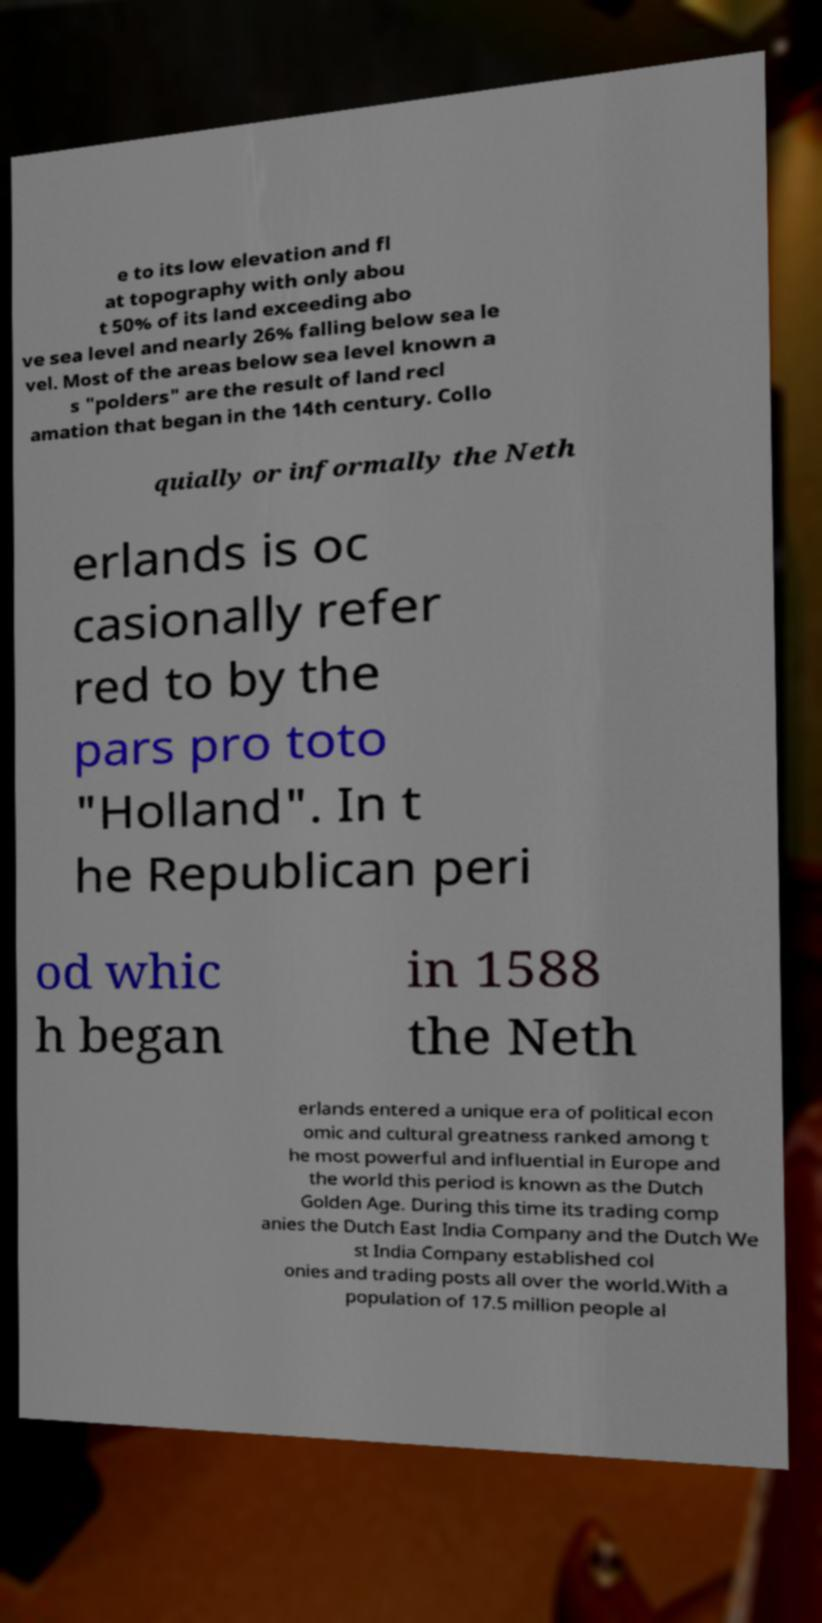Can you accurately transcribe the text from the provided image for me? e to its low elevation and fl at topography with only abou t 50% of its land exceeding abo ve sea level and nearly 26% falling below sea le vel. Most of the areas below sea level known a s "polders" are the result of land recl amation that began in the 14th century. Collo quially or informally the Neth erlands is oc casionally refer red to by the pars pro toto "Holland". In t he Republican peri od whic h began in 1588 the Neth erlands entered a unique era of political econ omic and cultural greatness ranked among t he most powerful and influential in Europe and the world this period is known as the Dutch Golden Age. During this time its trading comp anies the Dutch East India Company and the Dutch We st India Company established col onies and trading posts all over the world.With a population of 17.5 million people al 